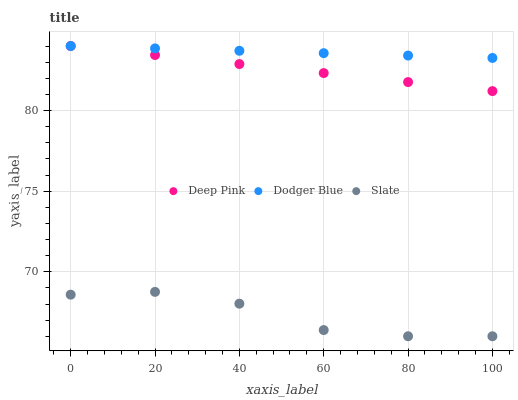Does Slate have the minimum area under the curve?
Answer yes or no. Yes. Does Dodger Blue have the maximum area under the curve?
Answer yes or no. Yes. Does Deep Pink have the minimum area under the curve?
Answer yes or no. No. Does Deep Pink have the maximum area under the curve?
Answer yes or no. No. Is Deep Pink the smoothest?
Answer yes or no. Yes. Is Slate the roughest?
Answer yes or no. Yes. Is Dodger Blue the smoothest?
Answer yes or no. No. Is Dodger Blue the roughest?
Answer yes or no. No. Does Slate have the lowest value?
Answer yes or no. Yes. Does Deep Pink have the lowest value?
Answer yes or no. No. Does Dodger Blue have the highest value?
Answer yes or no. Yes. Is Slate less than Deep Pink?
Answer yes or no. Yes. Is Deep Pink greater than Slate?
Answer yes or no. Yes. Does Dodger Blue intersect Deep Pink?
Answer yes or no. Yes. Is Dodger Blue less than Deep Pink?
Answer yes or no. No. Is Dodger Blue greater than Deep Pink?
Answer yes or no. No. Does Slate intersect Deep Pink?
Answer yes or no. No. 